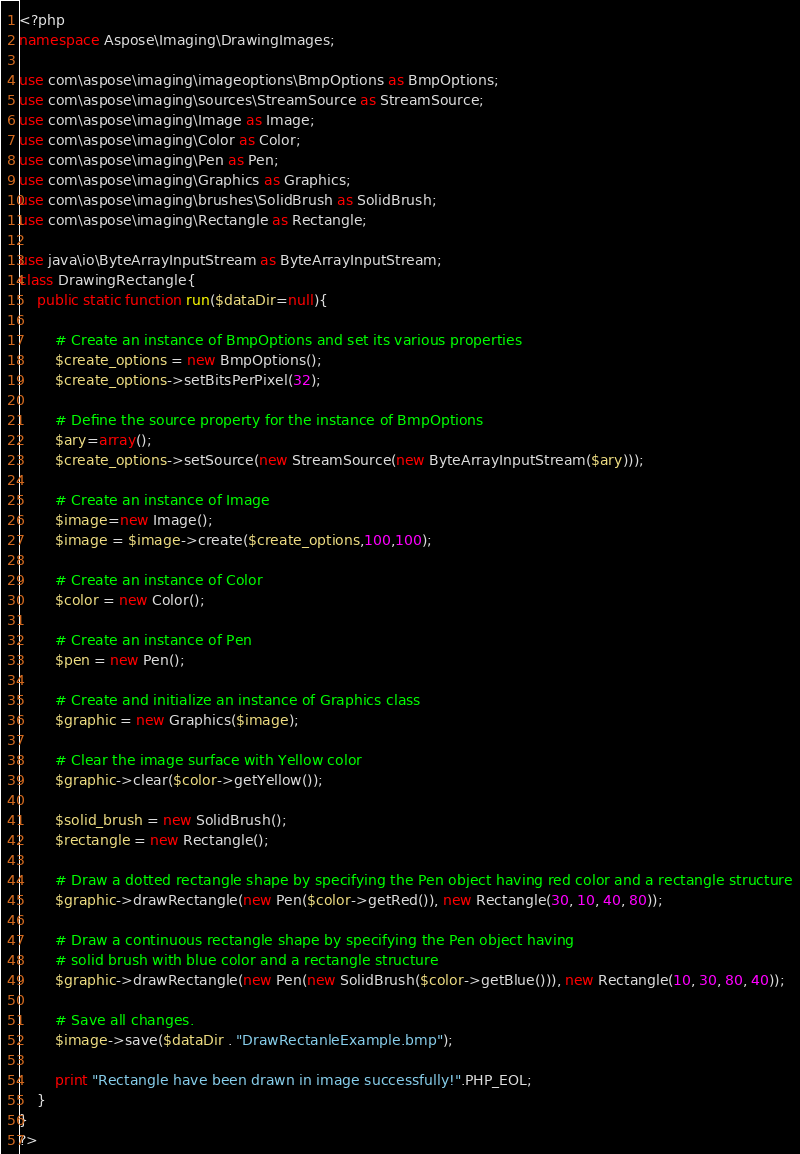<code> <loc_0><loc_0><loc_500><loc_500><_PHP_><?php
namespace Aspose\Imaging\DrawingImages;

use com\aspose\imaging\imageoptions\BmpOptions as BmpOptions;
use com\aspose\imaging\sources\StreamSource as StreamSource;
use com\aspose\imaging\Image as Image;
use com\aspose\imaging\Color as Color;
use com\aspose\imaging\Pen as Pen;
use com\aspose\imaging\Graphics as Graphics;
use com\aspose\imaging\brushes\SolidBrush as SolidBrush;
use com\aspose\imaging\Rectangle as Rectangle;

use java\io\ByteArrayInputStream as ByteArrayInputStream;
class DrawingRectangle{
    public static function run($dataDir=null){

        # Create an instance of BmpOptions and set its various properties
        $create_options = new BmpOptions();
        $create_options->setBitsPerPixel(32);

        # Define the source property for the instance of BmpOptions
        $ary=array();
        $create_options->setSource(new StreamSource(new ByteArrayInputStream($ary)));

        # Create an instance of Image
        $image=new Image();
        $image = $image->create($create_options,100,100);

        # Create an instance of Color
        $color = new Color();

        # Create an instance of Pen
        $pen = new Pen();

        # Create and initialize an instance of Graphics class
        $graphic = new Graphics($image);

        # Clear the image surface with Yellow color
        $graphic->clear($color->getYellow());

        $solid_brush = new SolidBrush();
        $rectangle = new Rectangle();

        # Draw a dotted rectangle shape by specifying the Pen object having red color and a rectangle structure
        $graphic->drawRectangle(new Pen($color->getRed()), new Rectangle(30, 10, 40, 80));

        # Draw a continuous rectangle shape by specifying the Pen object having
        # solid brush with blue color and a rectangle structure
        $graphic->drawRectangle(new Pen(new SolidBrush($color->getBlue())), new Rectangle(10, 30, 80, 40));

        # Save all changes.
        $image->save($dataDir . "DrawRectanleExample.bmp");

        print "Rectangle have been drawn in image successfully!".PHP_EOL;
    }
}
?></code> 